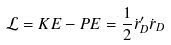Convert formula to latex. <formula><loc_0><loc_0><loc_500><loc_500>\mathcal { L } = K E - P E = \frac { 1 } { 2 } \dot { r } _ { D } ^ { \prime } \dot { r } _ { D }</formula> 